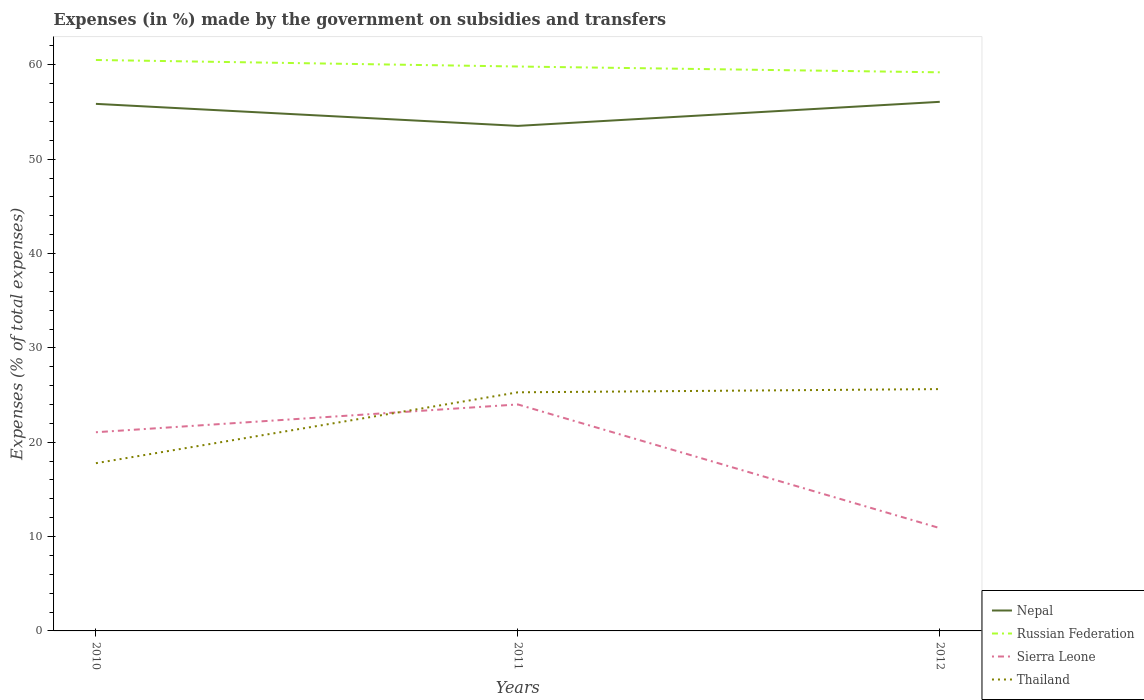How many different coloured lines are there?
Ensure brevity in your answer.  4. Does the line corresponding to Nepal intersect with the line corresponding to Sierra Leone?
Offer a very short reply. No. Is the number of lines equal to the number of legend labels?
Ensure brevity in your answer.  Yes. Across all years, what is the maximum percentage of expenses made by the government on subsidies and transfers in Russian Federation?
Your response must be concise. 59.21. What is the total percentage of expenses made by the government on subsidies and transfers in Thailand in the graph?
Provide a succinct answer. -7.85. What is the difference between the highest and the second highest percentage of expenses made by the government on subsidies and transfers in Thailand?
Offer a very short reply. 7.85. What is the difference between the highest and the lowest percentage of expenses made by the government on subsidies and transfers in Thailand?
Offer a terse response. 2. How many lines are there?
Ensure brevity in your answer.  4. How many years are there in the graph?
Keep it short and to the point. 3. What is the difference between two consecutive major ticks on the Y-axis?
Offer a terse response. 10. Are the values on the major ticks of Y-axis written in scientific E-notation?
Offer a terse response. No. How are the legend labels stacked?
Make the answer very short. Vertical. What is the title of the graph?
Your answer should be compact. Expenses (in %) made by the government on subsidies and transfers. What is the label or title of the Y-axis?
Offer a terse response. Expenses (% of total expenses). What is the Expenses (% of total expenses) of Nepal in 2010?
Your answer should be very brief. 55.87. What is the Expenses (% of total expenses) in Russian Federation in 2010?
Make the answer very short. 60.52. What is the Expenses (% of total expenses) in Sierra Leone in 2010?
Your answer should be very brief. 21.06. What is the Expenses (% of total expenses) in Thailand in 2010?
Keep it short and to the point. 17.78. What is the Expenses (% of total expenses) in Nepal in 2011?
Your answer should be very brief. 53.53. What is the Expenses (% of total expenses) of Russian Federation in 2011?
Your answer should be compact. 59.83. What is the Expenses (% of total expenses) of Sierra Leone in 2011?
Make the answer very short. 24.01. What is the Expenses (% of total expenses) of Thailand in 2011?
Make the answer very short. 25.29. What is the Expenses (% of total expenses) of Nepal in 2012?
Your response must be concise. 56.08. What is the Expenses (% of total expenses) of Russian Federation in 2012?
Offer a very short reply. 59.21. What is the Expenses (% of total expenses) of Sierra Leone in 2012?
Offer a terse response. 10.9. What is the Expenses (% of total expenses) of Thailand in 2012?
Ensure brevity in your answer.  25.63. Across all years, what is the maximum Expenses (% of total expenses) of Nepal?
Offer a terse response. 56.08. Across all years, what is the maximum Expenses (% of total expenses) of Russian Federation?
Provide a succinct answer. 60.52. Across all years, what is the maximum Expenses (% of total expenses) in Sierra Leone?
Offer a very short reply. 24.01. Across all years, what is the maximum Expenses (% of total expenses) in Thailand?
Offer a terse response. 25.63. Across all years, what is the minimum Expenses (% of total expenses) of Nepal?
Give a very brief answer. 53.53. Across all years, what is the minimum Expenses (% of total expenses) of Russian Federation?
Your response must be concise. 59.21. Across all years, what is the minimum Expenses (% of total expenses) in Sierra Leone?
Your answer should be very brief. 10.9. Across all years, what is the minimum Expenses (% of total expenses) in Thailand?
Your response must be concise. 17.78. What is the total Expenses (% of total expenses) in Nepal in the graph?
Provide a succinct answer. 165.48. What is the total Expenses (% of total expenses) in Russian Federation in the graph?
Offer a very short reply. 179.55. What is the total Expenses (% of total expenses) of Sierra Leone in the graph?
Make the answer very short. 55.96. What is the total Expenses (% of total expenses) of Thailand in the graph?
Your answer should be very brief. 68.7. What is the difference between the Expenses (% of total expenses) of Nepal in 2010 and that in 2011?
Offer a terse response. 2.33. What is the difference between the Expenses (% of total expenses) in Russian Federation in 2010 and that in 2011?
Keep it short and to the point. 0.69. What is the difference between the Expenses (% of total expenses) of Sierra Leone in 2010 and that in 2011?
Your answer should be very brief. -2.95. What is the difference between the Expenses (% of total expenses) of Thailand in 2010 and that in 2011?
Your answer should be very brief. -7.51. What is the difference between the Expenses (% of total expenses) in Nepal in 2010 and that in 2012?
Keep it short and to the point. -0.22. What is the difference between the Expenses (% of total expenses) of Russian Federation in 2010 and that in 2012?
Make the answer very short. 1.31. What is the difference between the Expenses (% of total expenses) in Sierra Leone in 2010 and that in 2012?
Offer a very short reply. 10.16. What is the difference between the Expenses (% of total expenses) in Thailand in 2010 and that in 2012?
Your response must be concise. -7.85. What is the difference between the Expenses (% of total expenses) of Nepal in 2011 and that in 2012?
Give a very brief answer. -2.55. What is the difference between the Expenses (% of total expenses) in Russian Federation in 2011 and that in 2012?
Offer a very short reply. 0.62. What is the difference between the Expenses (% of total expenses) in Sierra Leone in 2011 and that in 2012?
Keep it short and to the point. 13.11. What is the difference between the Expenses (% of total expenses) in Thailand in 2011 and that in 2012?
Your answer should be compact. -0.34. What is the difference between the Expenses (% of total expenses) of Nepal in 2010 and the Expenses (% of total expenses) of Russian Federation in 2011?
Your answer should be compact. -3.96. What is the difference between the Expenses (% of total expenses) of Nepal in 2010 and the Expenses (% of total expenses) of Sierra Leone in 2011?
Make the answer very short. 31.86. What is the difference between the Expenses (% of total expenses) of Nepal in 2010 and the Expenses (% of total expenses) of Thailand in 2011?
Your response must be concise. 30.57. What is the difference between the Expenses (% of total expenses) of Russian Federation in 2010 and the Expenses (% of total expenses) of Sierra Leone in 2011?
Ensure brevity in your answer.  36.51. What is the difference between the Expenses (% of total expenses) of Russian Federation in 2010 and the Expenses (% of total expenses) of Thailand in 2011?
Give a very brief answer. 35.23. What is the difference between the Expenses (% of total expenses) in Sierra Leone in 2010 and the Expenses (% of total expenses) in Thailand in 2011?
Provide a short and direct response. -4.23. What is the difference between the Expenses (% of total expenses) in Nepal in 2010 and the Expenses (% of total expenses) in Russian Federation in 2012?
Ensure brevity in your answer.  -3.34. What is the difference between the Expenses (% of total expenses) of Nepal in 2010 and the Expenses (% of total expenses) of Sierra Leone in 2012?
Make the answer very short. 44.97. What is the difference between the Expenses (% of total expenses) of Nepal in 2010 and the Expenses (% of total expenses) of Thailand in 2012?
Your answer should be compact. 30.23. What is the difference between the Expenses (% of total expenses) of Russian Federation in 2010 and the Expenses (% of total expenses) of Sierra Leone in 2012?
Ensure brevity in your answer.  49.62. What is the difference between the Expenses (% of total expenses) of Russian Federation in 2010 and the Expenses (% of total expenses) of Thailand in 2012?
Your response must be concise. 34.88. What is the difference between the Expenses (% of total expenses) of Sierra Leone in 2010 and the Expenses (% of total expenses) of Thailand in 2012?
Your response must be concise. -4.57. What is the difference between the Expenses (% of total expenses) of Nepal in 2011 and the Expenses (% of total expenses) of Russian Federation in 2012?
Keep it short and to the point. -5.68. What is the difference between the Expenses (% of total expenses) in Nepal in 2011 and the Expenses (% of total expenses) in Sierra Leone in 2012?
Give a very brief answer. 42.64. What is the difference between the Expenses (% of total expenses) of Nepal in 2011 and the Expenses (% of total expenses) of Thailand in 2012?
Keep it short and to the point. 27.9. What is the difference between the Expenses (% of total expenses) in Russian Federation in 2011 and the Expenses (% of total expenses) in Sierra Leone in 2012?
Make the answer very short. 48.93. What is the difference between the Expenses (% of total expenses) of Russian Federation in 2011 and the Expenses (% of total expenses) of Thailand in 2012?
Offer a very short reply. 34.19. What is the difference between the Expenses (% of total expenses) in Sierra Leone in 2011 and the Expenses (% of total expenses) in Thailand in 2012?
Your answer should be very brief. -1.63. What is the average Expenses (% of total expenses) of Nepal per year?
Offer a very short reply. 55.16. What is the average Expenses (% of total expenses) of Russian Federation per year?
Your answer should be compact. 59.85. What is the average Expenses (% of total expenses) of Sierra Leone per year?
Your response must be concise. 18.65. What is the average Expenses (% of total expenses) of Thailand per year?
Provide a short and direct response. 22.9. In the year 2010, what is the difference between the Expenses (% of total expenses) of Nepal and Expenses (% of total expenses) of Russian Federation?
Offer a very short reply. -4.65. In the year 2010, what is the difference between the Expenses (% of total expenses) in Nepal and Expenses (% of total expenses) in Sierra Leone?
Make the answer very short. 34.81. In the year 2010, what is the difference between the Expenses (% of total expenses) of Nepal and Expenses (% of total expenses) of Thailand?
Keep it short and to the point. 38.09. In the year 2010, what is the difference between the Expenses (% of total expenses) of Russian Federation and Expenses (% of total expenses) of Sierra Leone?
Your answer should be very brief. 39.46. In the year 2010, what is the difference between the Expenses (% of total expenses) of Russian Federation and Expenses (% of total expenses) of Thailand?
Offer a terse response. 42.74. In the year 2010, what is the difference between the Expenses (% of total expenses) in Sierra Leone and Expenses (% of total expenses) in Thailand?
Make the answer very short. 3.28. In the year 2011, what is the difference between the Expenses (% of total expenses) in Nepal and Expenses (% of total expenses) in Russian Federation?
Your answer should be very brief. -6.29. In the year 2011, what is the difference between the Expenses (% of total expenses) of Nepal and Expenses (% of total expenses) of Sierra Leone?
Your response must be concise. 29.53. In the year 2011, what is the difference between the Expenses (% of total expenses) in Nepal and Expenses (% of total expenses) in Thailand?
Give a very brief answer. 28.24. In the year 2011, what is the difference between the Expenses (% of total expenses) of Russian Federation and Expenses (% of total expenses) of Sierra Leone?
Ensure brevity in your answer.  35.82. In the year 2011, what is the difference between the Expenses (% of total expenses) of Russian Federation and Expenses (% of total expenses) of Thailand?
Your response must be concise. 34.53. In the year 2011, what is the difference between the Expenses (% of total expenses) of Sierra Leone and Expenses (% of total expenses) of Thailand?
Provide a short and direct response. -1.29. In the year 2012, what is the difference between the Expenses (% of total expenses) of Nepal and Expenses (% of total expenses) of Russian Federation?
Your answer should be very brief. -3.13. In the year 2012, what is the difference between the Expenses (% of total expenses) of Nepal and Expenses (% of total expenses) of Sierra Leone?
Provide a succinct answer. 45.19. In the year 2012, what is the difference between the Expenses (% of total expenses) in Nepal and Expenses (% of total expenses) in Thailand?
Provide a short and direct response. 30.45. In the year 2012, what is the difference between the Expenses (% of total expenses) in Russian Federation and Expenses (% of total expenses) in Sierra Leone?
Give a very brief answer. 48.31. In the year 2012, what is the difference between the Expenses (% of total expenses) in Russian Federation and Expenses (% of total expenses) in Thailand?
Your answer should be very brief. 33.58. In the year 2012, what is the difference between the Expenses (% of total expenses) of Sierra Leone and Expenses (% of total expenses) of Thailand?
Offer a terse response. -14.74. What is the ratio of the Expenses (% of total expenses) in Nepal in 2010 to that in 2011?
Your answer should be compact. 1.04. What is the ratio of the Expenses (% of total expenses) in Russian Federation in 2010 to that in 2011?
Offer a very short reply. 1.01. What is the ratio of the Expenses (% of total expenses) in Sierra Leone in 2010 to that in 2011?
Keep it short and to the point. 0.88. What is the ratio of the Expenses (% of total expenses) in Thailand in 2010 to that in 2011?
Provide a succinct answer. 0.7. What is the ratio of the Expenses (% of total expenses) in Russian Federation in 2010 to that in 2012?
Your response must be concise. 1.02. What is the ratio of the Expenses (% of total expenses) of Sierra Leone in 2010 to that in 2012?
Provide a succinct answer. 1.93. What is the ratio of the Expenses (% of total expenses) of Thailand in 2010 to that in 2012?
Offer a very short reply. 0.69. What is the ratio of the Expenses (% of total expenses) of Nepal in 2011 to that in 2012?
Give a very brief answer. 0.95. What is the ratio of the Expenses (% of total expenses) in Russian Federation in 2011 to that in 2012?
Your response must be concise. 1.01. What is the ratio of the Expenses (% of total expenses) in Sierra Leone in 2011 to that in 2012?
Provide a short and direct response. 2.2. What is the ratio of the Expenses (% of total expenses) in Thailand in 2011 to that in 2012?
Provide a succinct answer. 0.99. What is the difference between the highest and the second highest Expenses (% of total expenses) in Nepal?
Provide a short and direct response. 0.22. What is the difference between the highest and the second highest Expenses (% of total expenses) of Russian Federation?
Make the answer very short. 0.69. What is the difference between the highest and the second highest Expenses (% of total expenses) in Sierra Leone?
Your response must be concise. 2.95. What is the difference between the highest and the second highest Expenses (% of total expenses) in Thailand?
Provide a succinct answer. 0.34. What is the difference between the highest and the lowest Expenses (% of total expenses) in Nepal?
Offer a very short reply. 2.55. What is the difference between the highest and the lowest Expenses (% of total expenses) of Russian Federation?
Make the answer very short. 1.31. What is the difference between the highest and the lowest Expenses (% of total expenses) of Sierra Leone?
Provide a short and direct response. 13.11. What is the difference between the highest and the lowest Expenses (% of total expenses) of Thailand?
Make the answer very short. 7.85. 